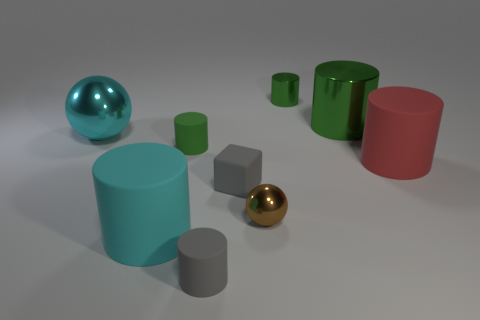What is the material of the large cylinder that is in front of the small metallic object in front of the tiny green cylinder in front of the large cyan sphere?
Provide a succinct answer. Rubber. Are there the same number of green objects that are in front of the block and red cubes?
Offer a terse response. Yes. Are there any other things that have the same size as the red matte cylinder?
Your response must be concise. Yes. How many objects are large red things or tiny gray blocks?
Make the answer very short. 2. There is a large cyan object that is made of the same material as the large red thing; what shape is it?
Offer a terse response. Cylinder. How big is the ball that is right of the cyan thing in front of the red cylinder?
Provide a succinct answer. Small. What number of large things are rubber cylinders or gray cylinders?
Keep it short and to the point. 2. How many other things are the same color as the large metallic sphere?
Provide a succinct answer. 1. There is a matte thing that is behind the red thing; is its size the same as the cyan object behind the big red cylinder?
Provide a succinct answer. No. Does the large green object have the same material as the tiny green object that is in front of the large cyan ball?
Keep it short and to the point. No. 